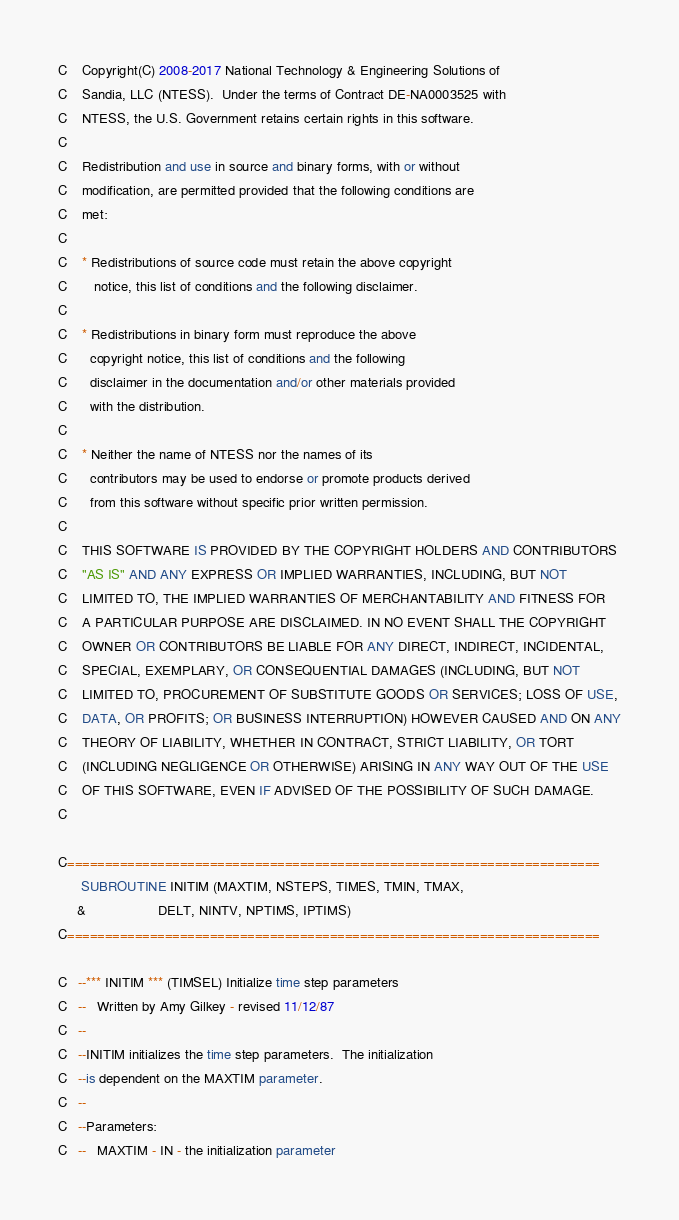<code> <loc_0><loc_0><loc_500><loc_500><_FORTRAN_>C    Copyright(C) 2008-2017 National Technology & Engineering Solutions of
C    Sandia, LLC (NTESS).  Under the terms of Contract DE-NA0003525 with
C    NTESS, the U.S. Government retains certain rights in this software.
C    
C    Redistribution and use in source and binary forms, with or without
C    modification, are permitted provided that the following conditions are
C    met:
C    
C    * Redistributions of source code must retain the above copyright
C       notice, this list of conditions and the following disclaimer.
C              
C    * Redistributions in binary form must reproduce the above
C      copyright notice, this list of conditions and the following
C      disclaimer in the documentation and/or other materials provided
C      with the distribution.
C                            
C    * Neither the name of NTESS nor the names of its
C      contributors may be used to endorse or promote products derived
C      from this software without specific prior written permission.
C                                                    
C    THIS SOFTWARE IS PROVIDED BY THE COPYRIGHT HOLDERS AND CONTRIBUTORS
C    "AS IS" AND ANY EXPRESS OR IMPLIED WARRANTIES, INCLUDING, BUT NOT
C    LIMITED TO, THE IMPLIED WARRANTIES OF MERCHANTABILITY AND FITNESS FOR
C    A PARTICULAR PURPOSE ARE DISCLAIMED. IN NO EVENT SHALL THE COPYRIGHT
C    OWNER OR CONTRIBUTORS BE LIABLE FOR ANY DIRECT, INDIRECT, INCIDENTAL,
C    SPECIAL, EXEMPLARY, OR CONSEQUENTIAL DAMAGES (INCLUDING, BUT NOT
C    LIMITED TO, PROCUREMENT OF SUBSTITUTE GOODS OR SERVICES; LOSS OF USE,
C    DATA, OR PROFITS; OR BUSINESS INTERRUPTION) HOWEVER CAUSED AND ON ANY
C    THEORY OF LIABILITY, WHETHER IN CONTRACT, STRICT LIABILITY, OR TORT
C    (INCLUDING NEGLIGENCE OR OTHERWISE) ARISING IN ANY WAY OUT OF THE USE
C    OF THIS SOFTWARE, EVEN IF ADVISED OF THE POSSIBILITY OF SUCH DAMAGE.
C    

C=======================================================================
      SUBROUTINE INITIM (MAXTIM, NSTEPS, TIMES, TMIN, TMAX,
     &                   DELT, NINTV, NPTIMS, IPTIMS)
C=======================================================================

C   --*** INITIM *** (TIMSEL) Initialize time step parameters
C   --   Written by Amy Gilkey - revised 11/12/87
C   --
C   --INITIM initializes the time step parameters.  The initialization
C   --is dependent on the MAXTIM parameter.
C   --
C   --Parameters:
C   --   MAXTIM - IN - the initialization parameter</code> 